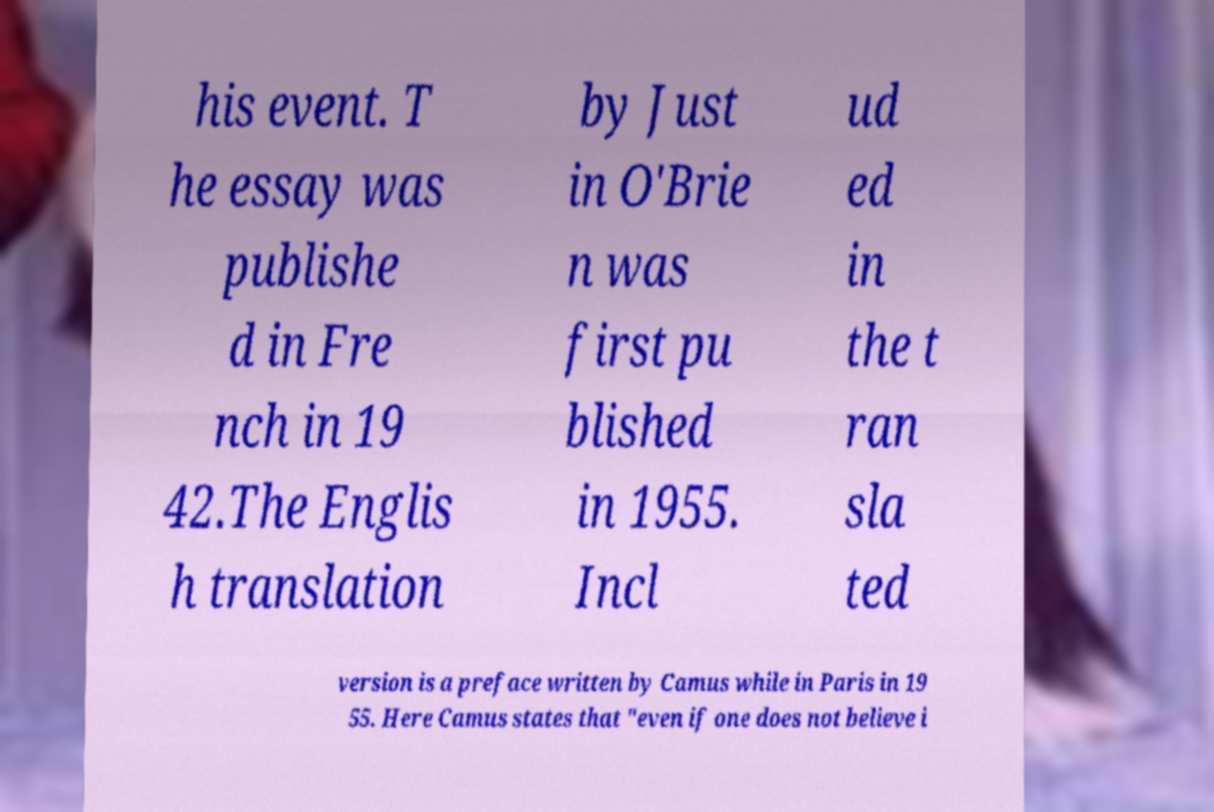I need the written content from this picture converted into text. Can you do that? his event. T he essay was publishe d in Fre nch in 19 42.The Englis h translation by Just in O'Brie n was first pu blished in 1955. Incl ud ed in the t ran sla ted version is a preface written by Camus while in Paris in 19 55. Here Camus states that "even if one does not believe i 